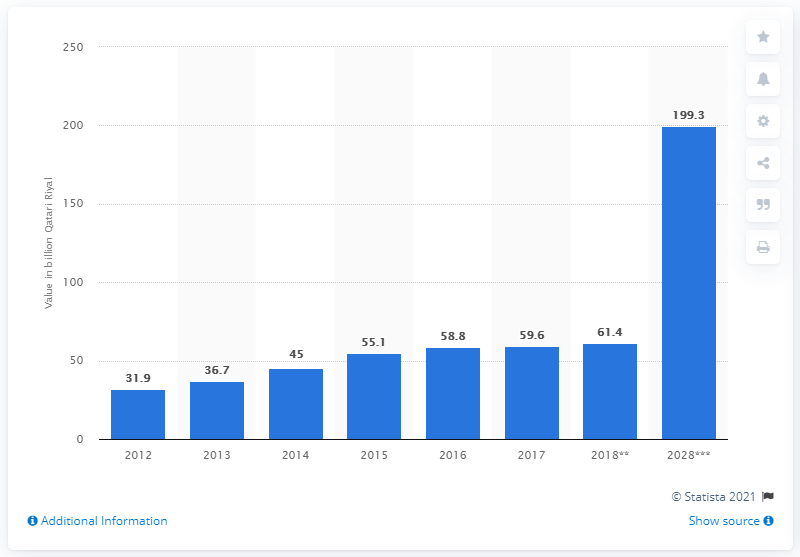Identify some key points in this picture. The estimated Gross Domestic Product of Qatar in Qatari Riyal in 2028 is 199.3 billion. 